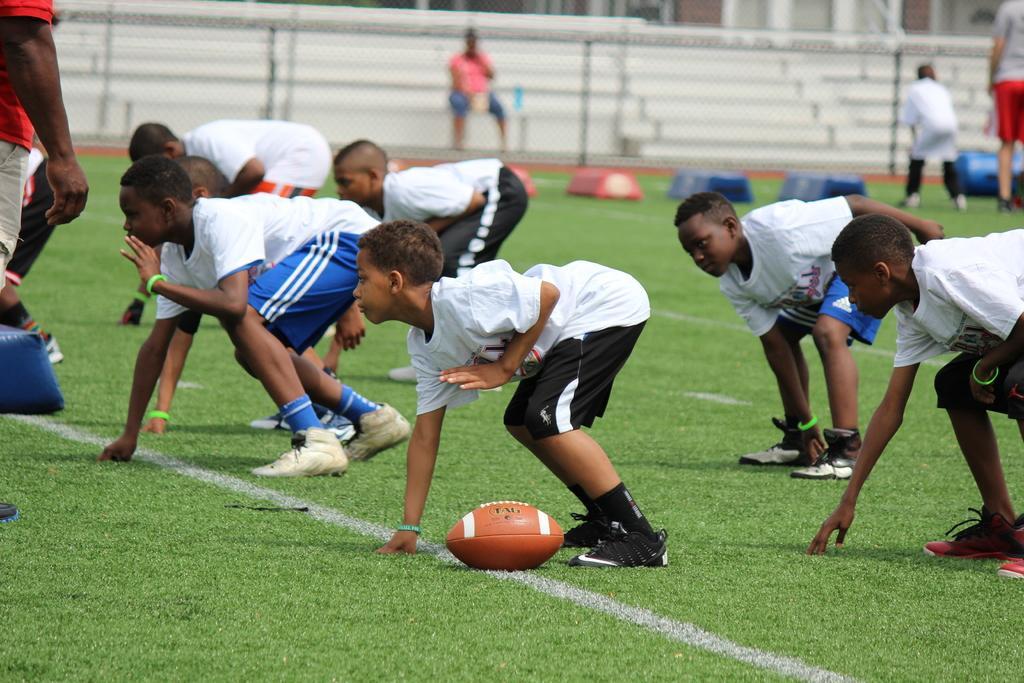In one or two sentences, can you explain what this image depicts? In the picture I can see people among them some are standing and some children are crouching on the ground. In the background I can see steps, fence, the grass and a ball on the ground. The background of the image is blurred. 